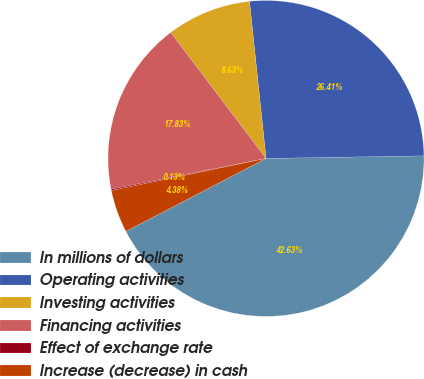Convert chart to OTSL. <chart><loc_0><loc_0><loc_500><loc_500><pie_chart><fcel>In millions of dollars<fcel>Operating activities<fcel>Investing activities<fcel>Financing activities<fcel>Effect of exchange rate<fcel>Increase (decrease) in cash<nl><fcel>42.63%<fcel>26.41%<fcel>8.63%<fcel>17.83%<fcel>0.13%<fcel>4.38%<nl></chart> 